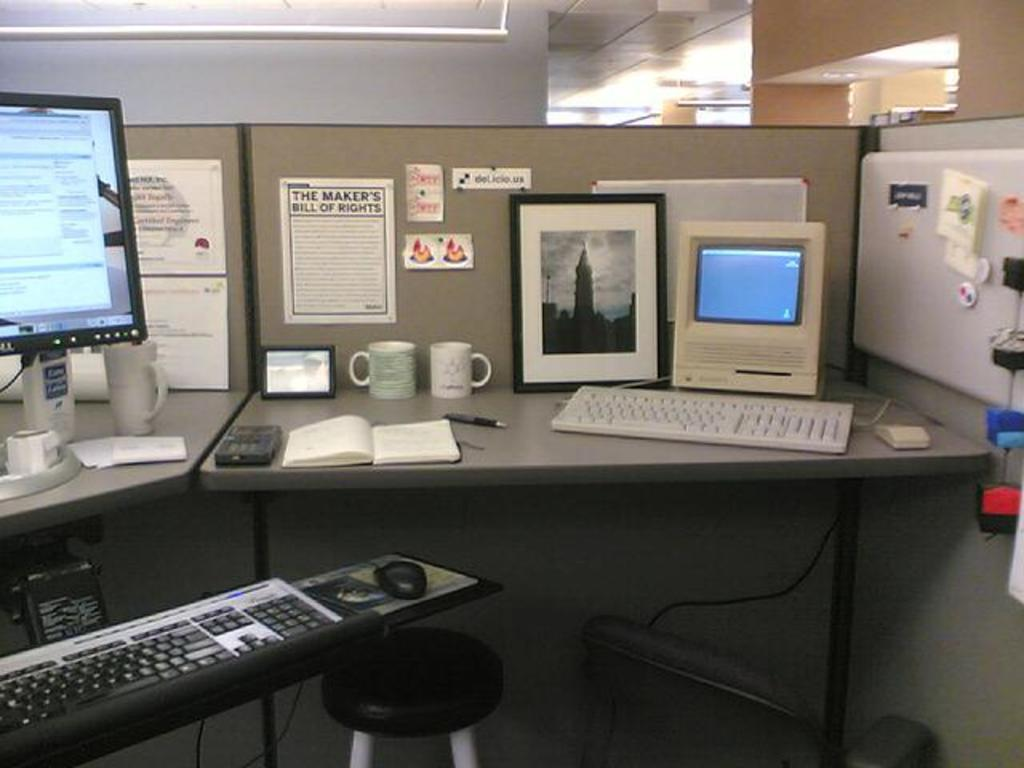Provide a one-sentence caption for the provided image. An office cubicle with The Maker's Bill of Rights on the wall. 